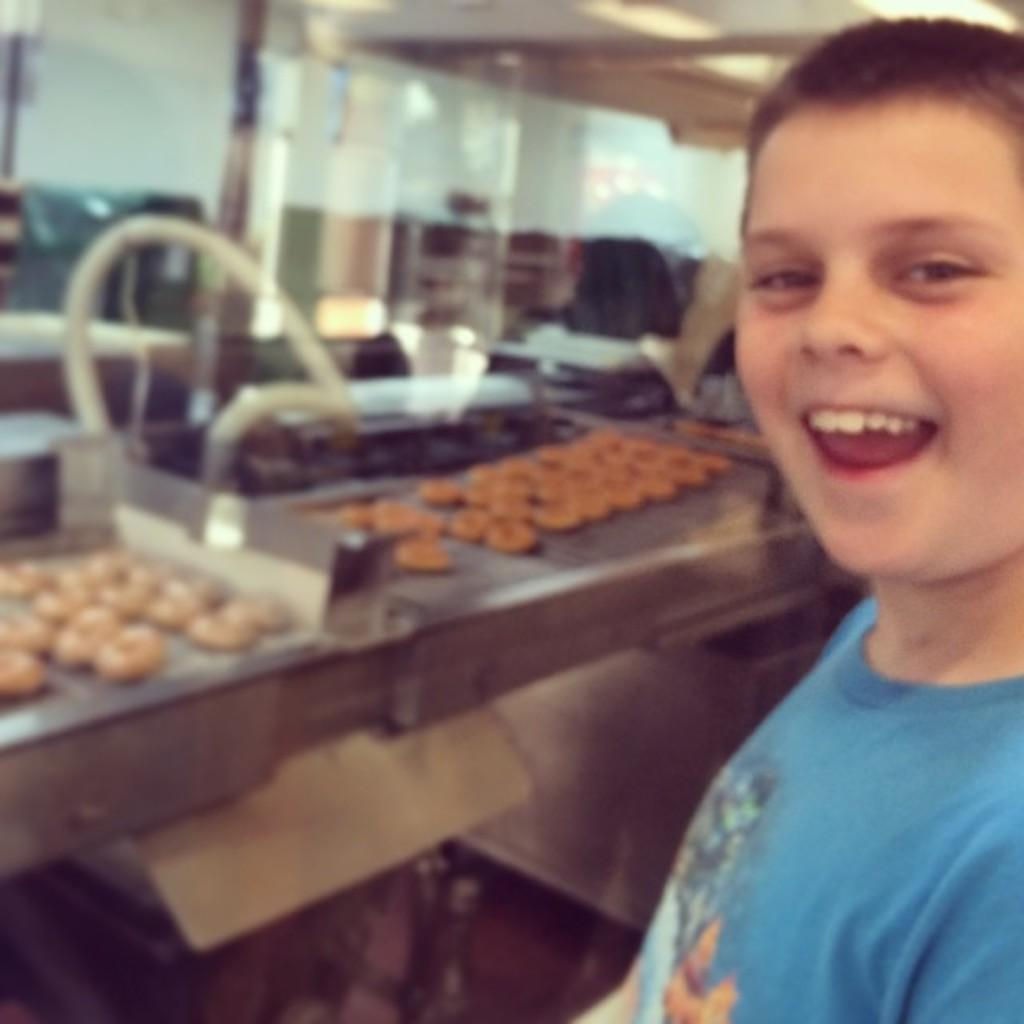Who is present in the image? There is a boy in the image. What is placed on the metal stand? There are donuts placed on a metal stand. What can be seen in the image that might be used for communication or entertainment? There are devices visible in the image. What architectural feature is present in the image? There is a pole in the image. What type of structure is visible in the image? There is a wall in the image. What is the source of light in the image? There is a roof with ceiling lights in the image. What type of collar is the boy wearing in the image? There is no collar visible on the boy in the image. 